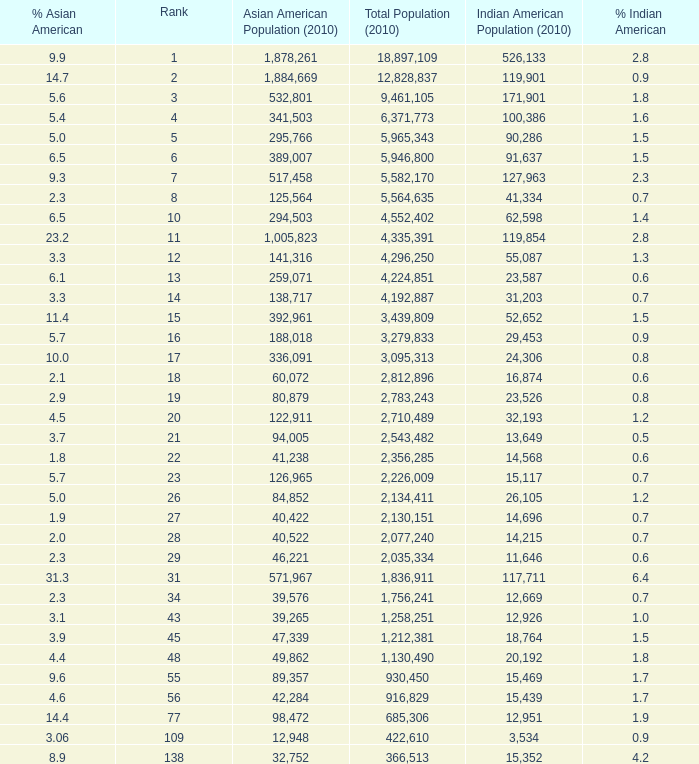What's the total population when the Asian American population is less than 60,072, the Indian American population is more than 14,696 and is 4.2% Indian American? 366513.0. 